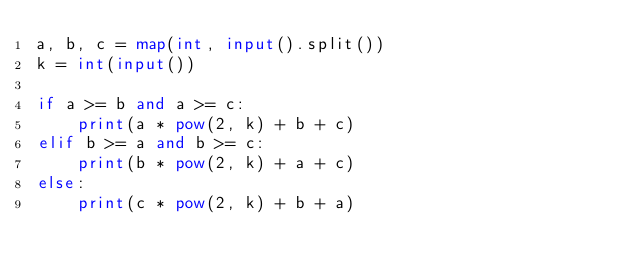<code> <loc_0><loc_0><loc_500><loc_500><_Python_>a, b, c = map(int, input().split())
k = int(input())

if a >= b and a >= c:
    print(a * pow(2, k) + b + c)
elif b >= a and b >= c:
    print(b * pow(2, k) + a + c)
else:
    print(c * pow(2, k) + b + a)
</code> 